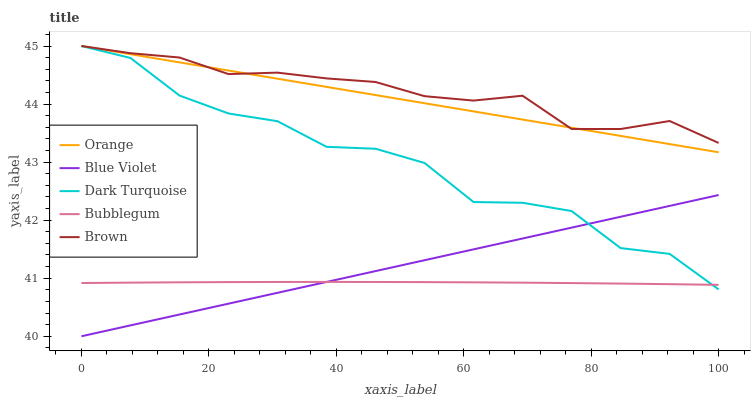Does Bubblegum have the minimum area under the curve?
Answer yes or no. Yes. Does Brown have the maximum area under the curve?
Answer yes or no. Yes. Does Dark Turquoise have the minimum area under the curve?
Answer yes or no. No. Does Dark Turquoise have the maximum area under the curve?
Answer yes or no. No. Is Orange the smoothest?
Answer yes or no. Yes. Is Dark Turquoise the roughest?
Answer yes or no. Yes. Is Bubblegum the smoothest?
Answer yes or no. No. Is Bubblegum the roughest?
Answer yes or no. No. Does Blue Violet have the lowest value?
Answer yes or no. Yes. Does Dark Turquoise have the lowest value?
Answer yes or no. No. Does Brown have the highest value?
Answer yes or no. Yes. Does Bubblegum have the highest value?
Answer yes or no. No. Is Bubblegum less than Brown?
Answer yes or no. Yes. Is Brown greater than Bubblegum?
Answer yes or no. Yes. Does Orange intersect Brown?
Answer yes or no. Yes. Is Orange less than Brown?
Answer yes or no. No. Is Orange greater than Brown?
Answer yes or no. No. Does Bubblegum intersect Brown?
Answer yes or no. No. 